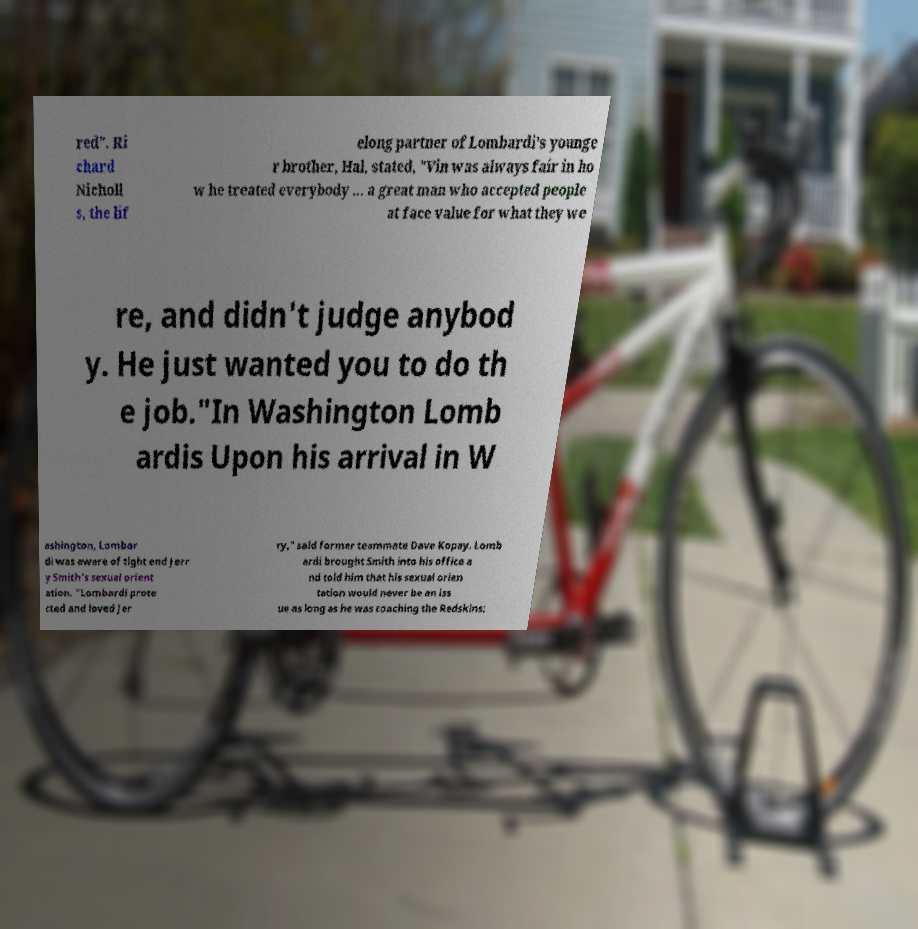There's text embedded in this image that I need extracted. Can you transcribe it verbatim? red". Ri chard Nicholl s, the lif elong partner of Lombardi's younge r brother, Hal, stated, "Vin was always fair in ho w he treated everybody ... a great man who accepted people at face value for what they we re, and didn't judge anybod y. He just wanted you to do th e job."In Washington Lomb ardis Upon his arrival in W ashington, Lombar di was aware of tight end Jerr y Smith's sexual orient ation. "Lombardi prote cted and loved Jer ry," said former teammate Dave Kopay. Lomb ardi brought Smith into his office a nd told him that his sexual orien tation would never be an iss ue as long as he was coaching the Redskins; 